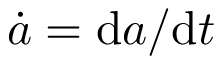<formula> <loc_0><loc_0><loc_500><loc_500>\dot { a } = d a / d t</formula> 